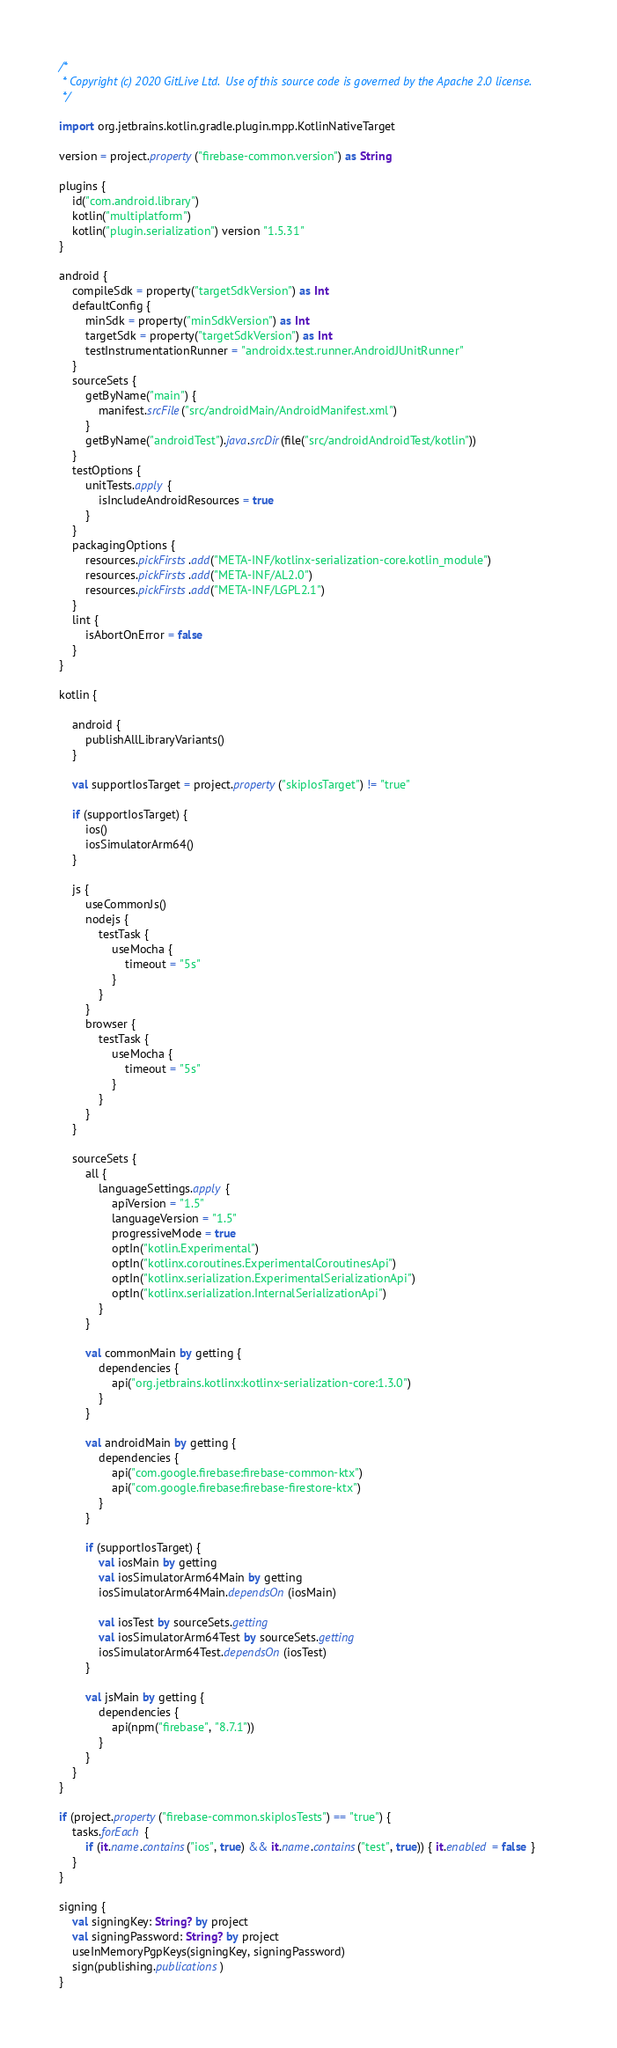Convert code to text. <code><loc_0><loc_0><loc_500><loc_500><_Kotlin_>/*
 * Copyright (c) 2020 GitLive Ltd.  Use of this source code is governed by the Apache 2.0 license.
 */

import org.jetbrains.kotlin.gradle.plugin.mpp.KotlinNativeTarget

version = project.property("firebase-common.version") as String

plugins {
    id("com.android.library")
    kotlin("multiplatform")
    kotlin("plugin.serialization") version "1.5.31"
}

android {
    compileSdk = property("targetSdkVersion") as Int
    defaultConfig {
        minSdk = property("minSdkVersion") as Int
        targetSdk = property("targetSdkVersion") as Int
        testInstrumentationRunner = "androidx.test.runner.AndroidJUnitRunner"
    }
    sourceSets {
        getByName("main") {
            manifest.srcFile("src/androidMain/AndroidManifest.xml")
        }
        getByName("androidTest").java.srcDir(file("src/androidAndroidTest/kotlin"))
    }
    testOptions {
        unitTests.apply {
            isIncludeAndroidResources = true
        }
    }
    packagingOptions {
        resources.pickFirsts.add("META-INF/kotlinx-serialization-core.kotlin_module")
        resources.pickFirsts.add("META-INF/AL2.0")
        resources.pickFirsts.add("META-INF/LGPL2.1")
    }
    lint {
        isAbortOnError = false
    }
}

kotlin {

    android {
        publishAllLibraryVariants()
    }

    val supportIosTarget = project.property("skipIosTarget") != "true"

    if (supportIosTarget) {
        ios()
        iosSimulatorArm64()
    }

    js {
        useCommonJs()
        nodejs {
            testTask {
                useMocha {
                    timeout = "5s"
                }
            }
        }
        browser {
            testTask {
                useMocha {
                    timeout = "5s"
                }
            }
        }
    }

    sourceSets {
        all {
            languageSettings.apply {
                apiVersion = "1.5"
                languageVersion = "1.5"
                progressiveMode = true
                optIn("kotlin.Experimental")
                optIn("kotlinx.coroutines.ExperimentalCoroutinesApi")
                optIn("kotlinx.serialization.ExperimentalSerializationApi")
                optIn("kotlinx.serialization.InternalSerializationApi")
            }
        }

        val commonMain by getting {
            dependencies {
                api("org.jetbrains.kotlinx:kotlinx-serialization-core:1.3.0")
            }
        }

        val androidMain by getting {
            dependencies {
                api("com.google.firebase:firebase-common-ktx")
                api("com.google.firebase:firebase-firestore-ktx")
            }
        }

        if (supportIosTarget) {
            val iosMain by getting
            val iosSimulatorArm64Main by getting
            iosSimulatorArm64Main.dependsOn(iosMain)

            val iosTest by sourceSets.getting
            val iosSimulatorArm64Test by sourceSets.getting
            iosSimulatorArm64Test.dependsOn(iosTest)
        }

        val jsMain by getting {
            dependencies {
                api(npm("firebase", "8.7.1"))
            }
        }
    }
}

if (project.property("firebase-common.skipIosTests") == "true") {
    tasks.forEach {
        if (it.name.contains("ios", true) && it.name.contains("test", true)) { it.enabled = false }
    }
}

signing {
    val signingKey: String? by project
    val signingPassword: String? by project
    useInMemoryPgpKeys(signingKey, signingPassword)
    sign(publishing.publications)
}

</code> 